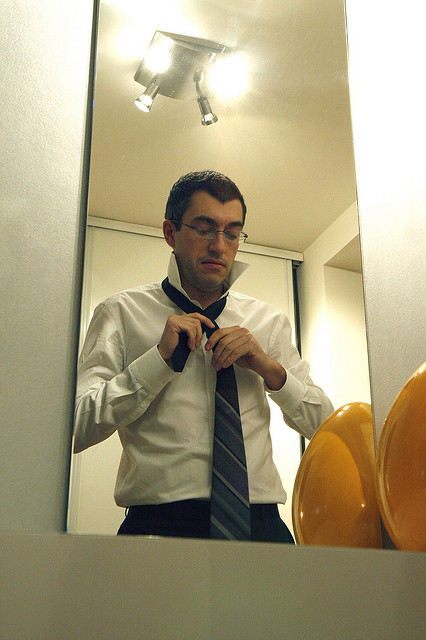How many buttons are visible in the image? In the image, there are three buttons visible on the man's white shirt. It highlights his meticulous attention to detail as he prepares himself. 